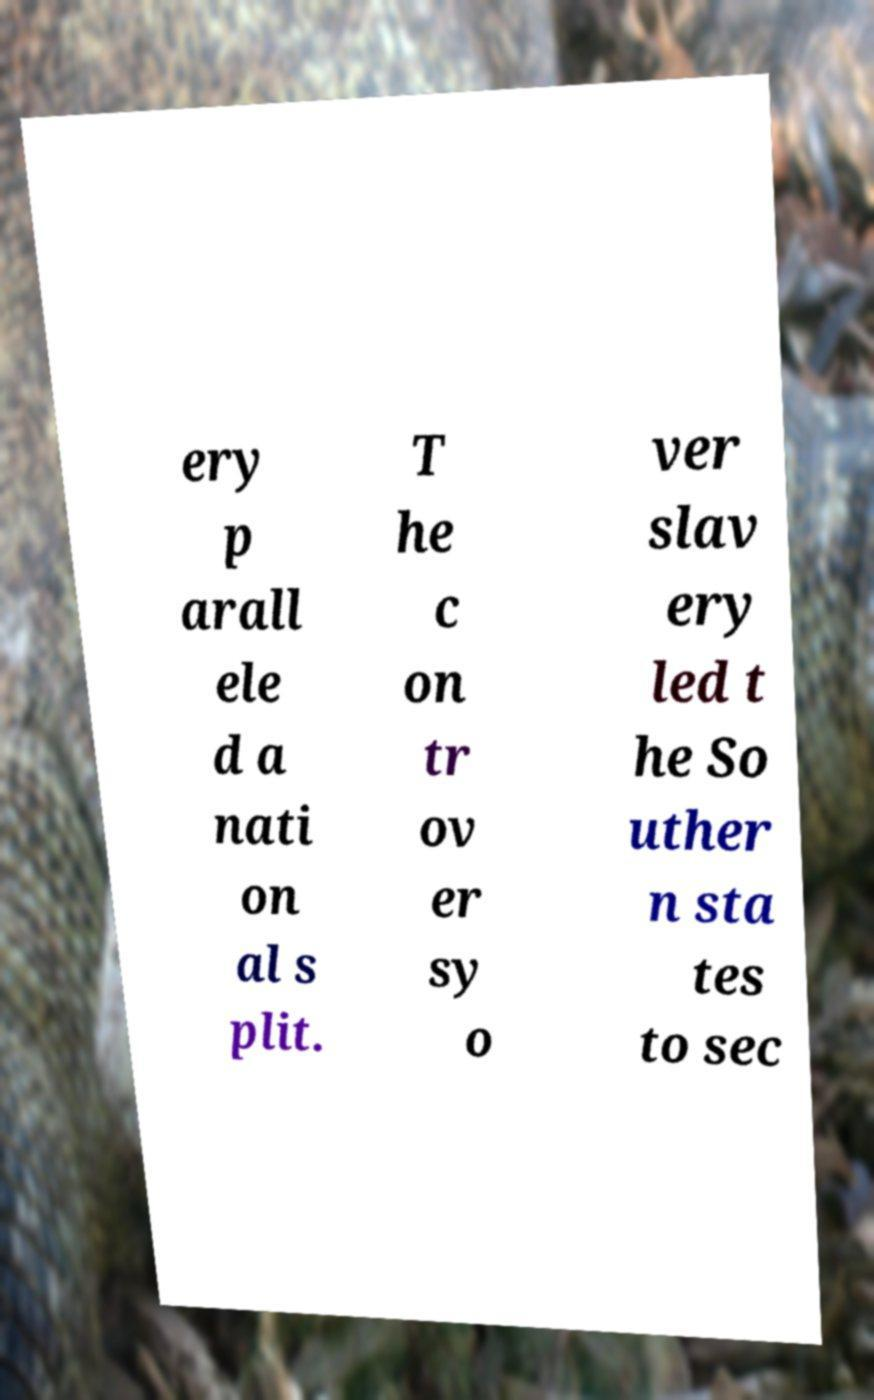Can you accurately transcribe the text from the provided image for me? ery p arall ele d a nati on al s plit. T he c on tr ov er sy o ver slav ery led t he So uther n sta tes to sec 